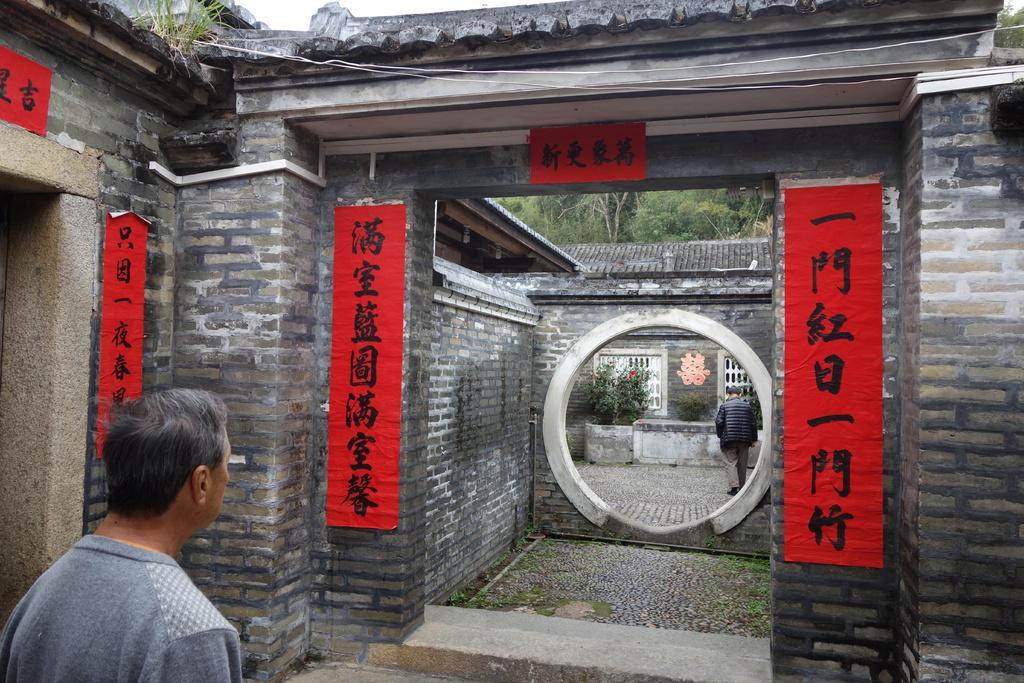Can you describe this image briefly? In this image I can see two persons, where one is standing in the front and another one is standing in the background. I can also see few red colour boards in the front and on it I can see something is written. In the background I can see few plants and few trees. 